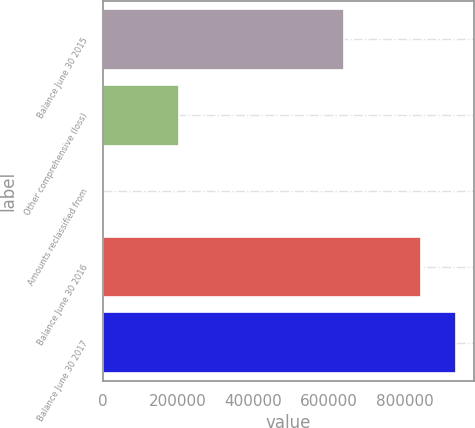<chart> <loc_0><loc_0><loc_500><loc_500><bar_chart><fcel>Balance June 30 2015<fcel>Other comprehensive (loss)<fcel>Amounts reclassified from<fcel>Balance June 30 2016<fcel>Balance June 30 2017<nl><fcel>641018<fcel>202444<fcel>659<fcel>844121<fcel>936589<nl></chart> 